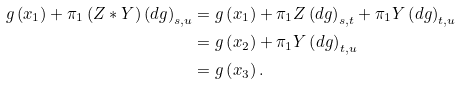<formula> <loc_0><loc_0><loc_500><loc_500>g \left ( x _ { 1 } \right ) + \pi _ { 1 } \left ( Z \ast Y \right ) \left ( d g \right ) _ { s , u } & = g \left ( x _ { 1 } \right ) + \pi _ { 1 } Z \left ( d g \right ) _ { s , t } + \pi _ { 1 } Y \left ( d g \right ) _ { t , u } \\ & = g \left ( x _ { 2 } \right ) + \pi _ { 1 } Y \left ( d g \right ) _ { t , u } \\ & = g \left ( x _ { 3 } \right ) .</formula> 